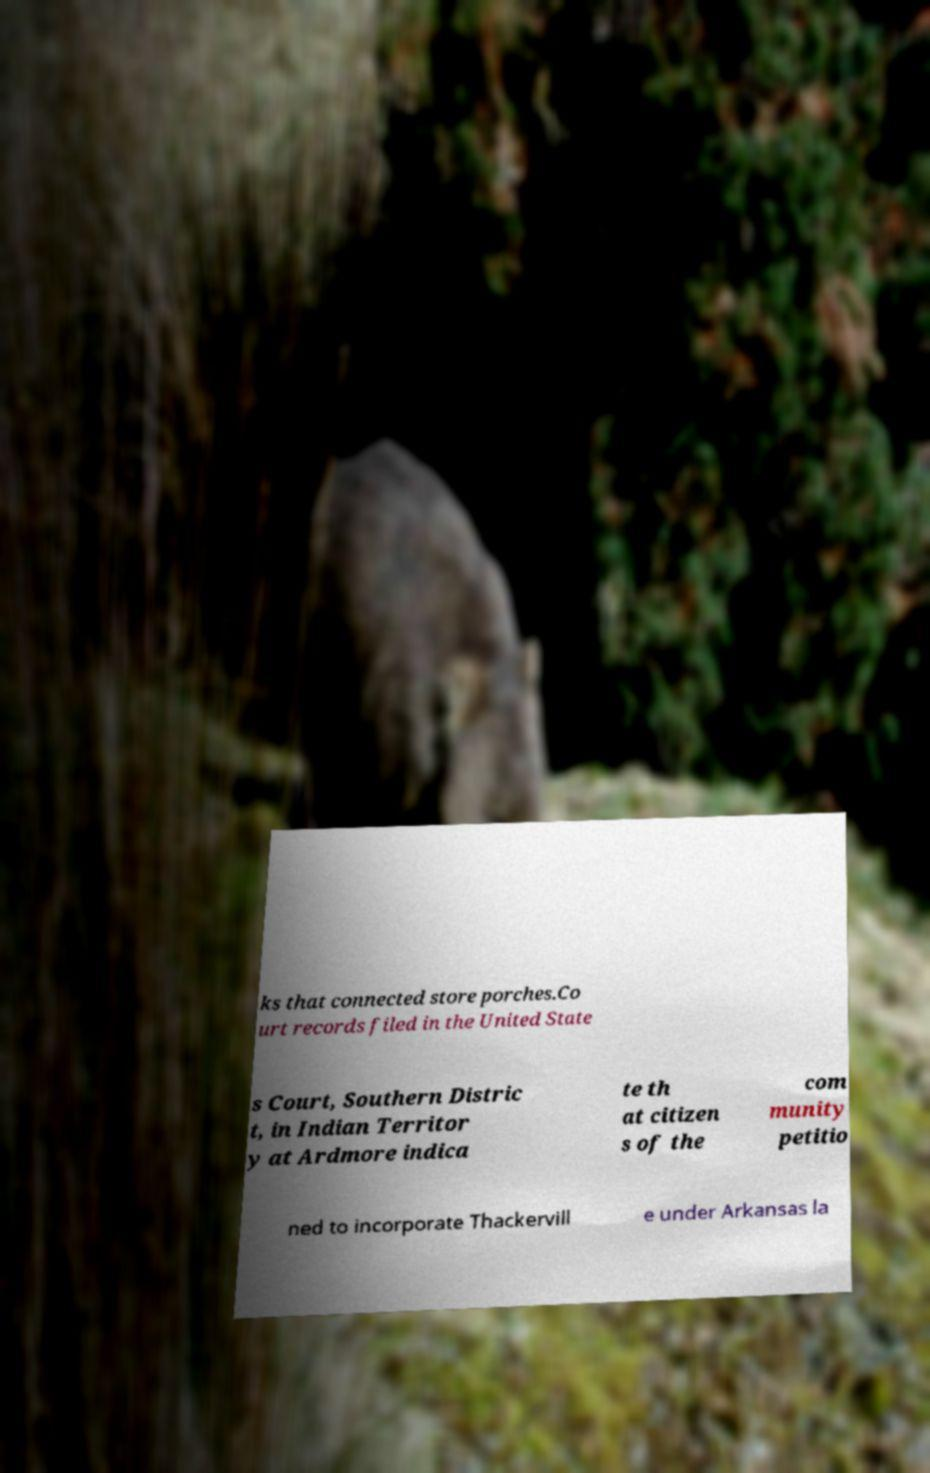Can you read and provide the text displayed in the image?This photo seems to have some interesting text. Can you extract and type it out for me? ks that connected store porches.Co urt records filed in the United State s Court, Southern Distric t, in Indian Territor y at Ardmore indica te th at citizen s of the com munity petitio ned to incorporate Thackervill e under Arkansas la 